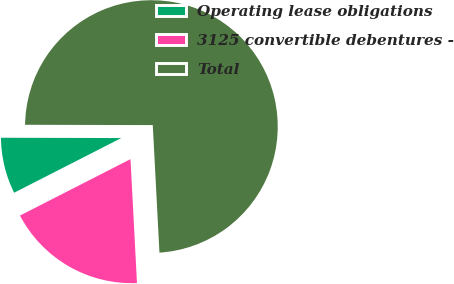Convert chart to OTSL. <chart><loc_0><loc_0><loc_500><loc_500><pie_chart><fcel>Operating lease obligations<fcel>3125 convertible debentures -<fcel>Total<nl><fcel>7.55%<fcel>18.32%<fcel>74.13%<nl></chart> 